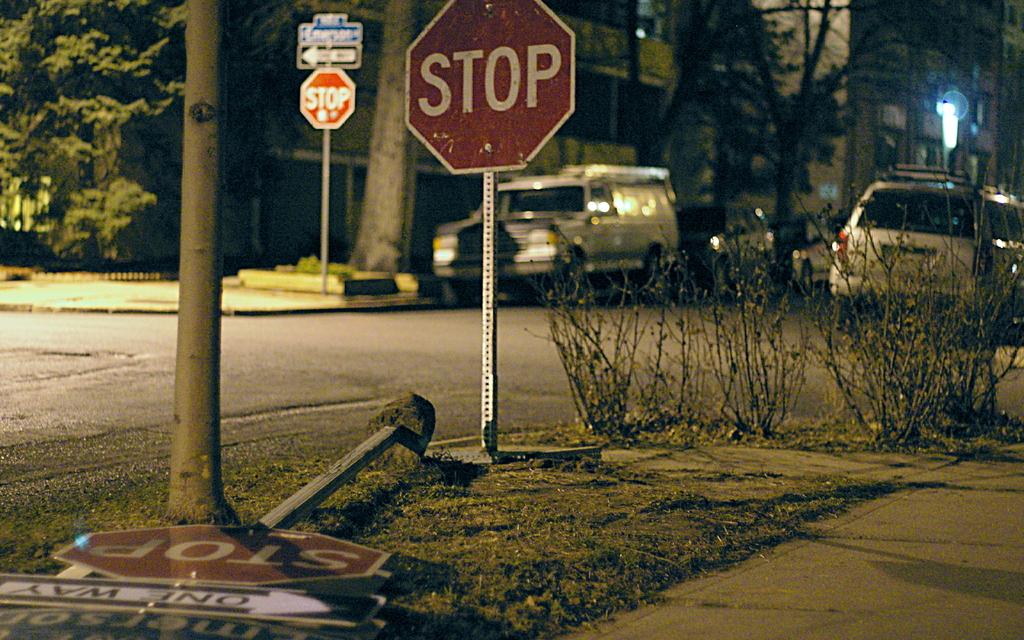What does the sign want the driver to do?
Make the answer very short. Stop. What does the black and white sign on the ground say?
Give a very brief answer. One way. 